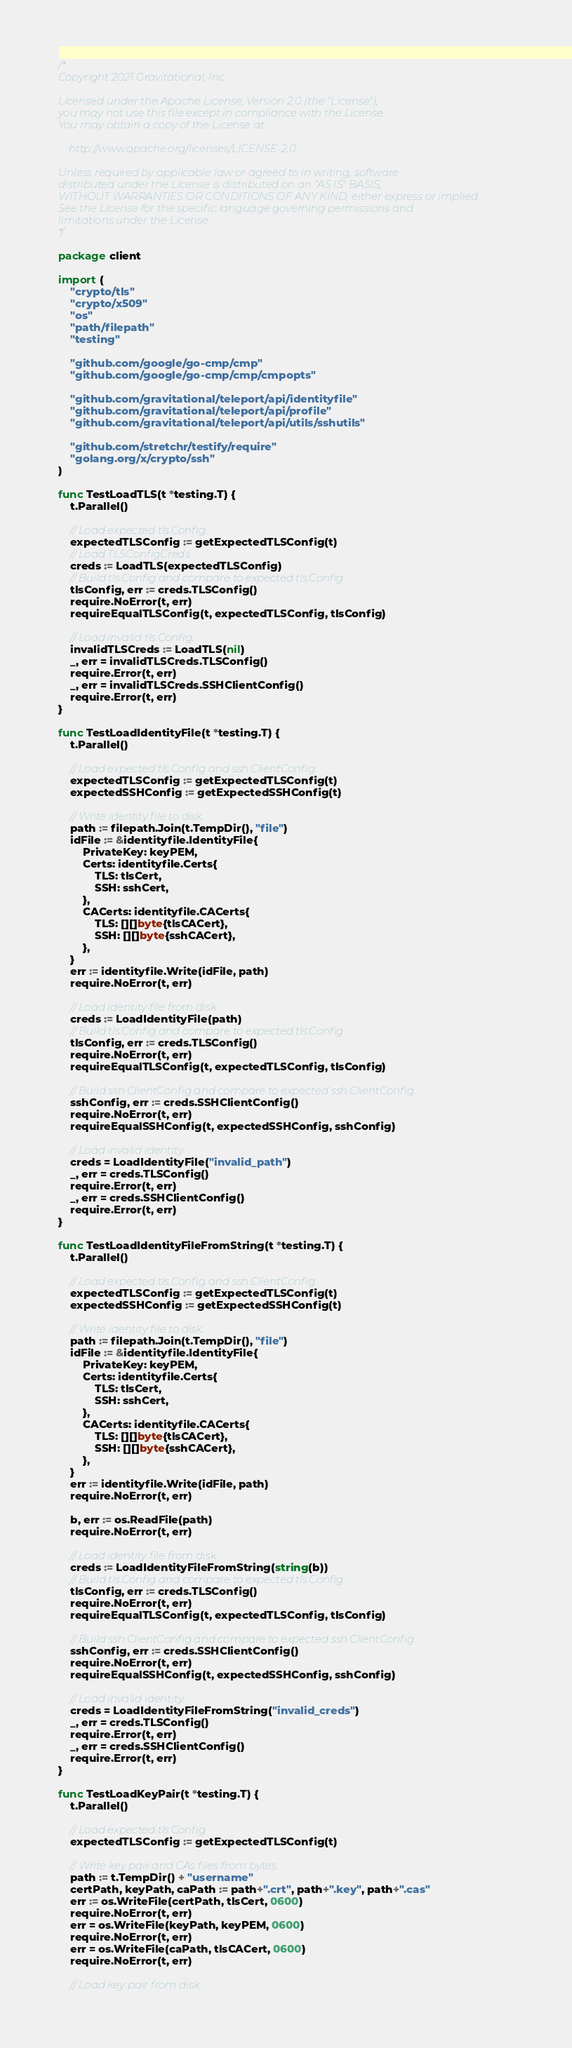<code> <loc_0><loc_0><loc_500><loc_500><_Go_>/*
Copyright 2021 Gravitational, Inc.

Licensed under the Apache License, Version 2.0 (the "License");
you may not use this file except in compliance with the License.
You may obtain a copy of the License at

    http://www.apache.org/licenses/LICENSE-2.0

Unless required by applicable law or agreed to in writing, software
distributed under the License is distributed on an "AS IS" BASIS,
WITHOUT WARRANTIES OR CONDITIONS OF ANY KIND, either express or implied.
See the License for the specific language governing permissions and
limitations under the License.
*/

package client

import (
	"crypto/tls"
	"crypto/x509"
	"os"
	"path/filepath"
	"testing"

	"github.com/google/go-cmp/cmp"
	"github.com/google/go-cmp/cmp/cmpopts"

	"github.com/gravitational/teleport/api/identityfile"
	"github.com/gravitational/teleport/api/profile"
	"github.com/gravitational/teleport/api/utils/sshutils"

	"github.com/stretchr/testify/require"
	"golang.org/x/crypto/ssh"
)

func TestLoadTLS(t *testing.T) {
	t.Parallel()

	// Load expected tls.Config.
	expectedTLSConfig := getExpectedTLSConfig(t)
	// Load TLSConfigCreds.
	creds := LoadTLS(expectedTLSConfig)
	// Build tls.Config and compare to expected tls.Config.
	tlsConfig, err := creds.TLSConfig()
	require.NoError(t, err)
	requireEqualTLSConfig(t, expectedTLSConfig, tlsConfig)

	// Load invalid tls.Config.
	invalidTLSCreds := LoadTLS(nil)
	_, err = invalidTLSCreds.TLSConfig()
	require.Error(t, err)
	_, err = invalidTLSCreds.SSHClientConfig()
	require.Error(t, err)
}

func TestLoadIdentityFile(t *testing.T) {
	t.Parallel()

	// Load expected tls.Config and ssh.ClientConfig.
	expectedTLSConfig := getExpectedTLSConfig(t)
	expectedSSHConfig := getExpectedSSHConfig(t)

	// Write identity file to disk.
	path := filepath.Join(t.TempDir(), "file")
	idFile := &identityfile.IdentityFile{
		PrivateKey: keyPEM,
		Certs: identityfile.Certs{
			TLS: tlsCert,
			SSH: sshCert,
		},
		CACerts: identityfile.CACerts{
			TLS: [][]byte{tlsCACert},
			SSH: [][]byte{sshCACert},
		},
	}
	err := identityfile.Write(idFile, path)
	require.NoError(t, err)

	// Load identity file from disk.
	creds := LoadIdentityFile(path)
	// Build tls.Config and compare to expected tls.Config.
	tlsConfig, err := creds.TLSConfig()
	require.NoError(t, err)
	requireEqualTLSConfig(t, expectedTLSConfig, tlsConfig)

	// Build ssh.ClientConfig and compare to expected ssh.ClientConfig.
	sshConfig, err := creds.SSHClientConfig()
	require.NoError(t, err)
	requireEqualSSHConfig(t, expectedSSHConfig, sshConfig)

	// Load invalid identity.
	creds = LoadIdentityFile("invalid_path")
	_, err = creds.TLSConfig()
	require.Error(t, err)
	_, err = creds.SSHClientConfig()
	require.Error(t, err)
}

func TestLoadIdentityFileFromString(t *testing.T) {
	t.Parallel()

	// Load expected tls.Config and ssh.ClientConfig.
	expectedTLSConfig := getExpectedTLSConfig(t)
	expectedSSHConfig := getExpectedSSHConfig(t)

	// Write identity file to disk.
	path := filepath.Join(t.TempDir(), "file")
	idFile := &identityfile.IdentityFile{
		PrivateKey: keyPEM,
		Certs: identityfile.Certs{
			TLS: tlsCert,
			SSH: sshCert,
		},
		CACerts: identityfile.CACerts{
			TLS: [][]byte{tlsCACert},
			SSH: [][]byte{sshCACert},
		},
	}
	err := identityfile.Write(idFile, path)
	require.NoError(t, err)

	b, err := os.ReadFile(path)
	require.NoError(t, err)

	// Load identity file from disk.
	creds := LoadIdentityFileFromString(string(b))
	// Build tls.Config and compare to expected tls.Config.
	tlsConfig, err := creds.TLSConfig()
	require.NoError(t, err)
	requireEqualTLSConfig(t, expectedTLSConfig, tlsConfig)

	// Build ssh.ClientConfig and compare to expected ssh.ClientConfig.
	sshConfig, err := creds.SSHClientConfig()
	require.NoError(t, err)
	requireEqualSSHConfig(t, expectedSSHConfig, sshConfig)

	// Load invalid identity.
	creds = LoadIdentityFileFromString("invalid_creds")
	_, err = creds.TLSConfig()
	require.Error(t, err)
	_, err = creds.SSHClientConfig()
	require.Error(t, err)
}

func TestLoadKeyPair(t *testing.T) {
	t.Parallel()

	// Load expected tls.Config.
	expectedTLSConfig := getExpectedTLSConfig(t)

	// Write key pair and CAs files from bytes.
	path := t.TempDir() + "username"
	certPath, keyPath, caPath := path+".crt", path+".key", path+".cas"
	err := os.WriteFile(certPath, tlsCert, 0600)
	require.NoError(t, err)
	err = os.WriteFile(keyPath, keyPEM, 0600)
	require.NoError(t, err)
	err = os.WriteFile(caPath, tlsCACert, 0600)
	require.NoError(t, err)

	// Load key pair from disk.</code> 